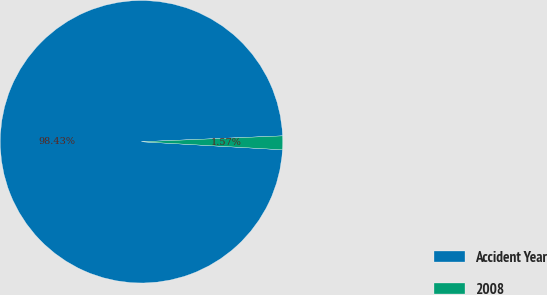Convert chart. <chart><loc_0><loc_0><loc_500><loc_500><pie_chart><fcel>Accident Year<fcel>2008<nl><fcel>98.43%<fcel>1.57%<nl></chart> 